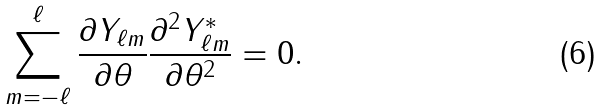Convert formula to latex. <formula><loc_0><loc_0><loc_500><loc_500>\sum _ { m = - \ell } ^ { \ell } \frac { \partial Y _ { \ell m } } { \partial \theta } \frac { \partial ^ { 2 } Y _ { \ell m } ^ { * } } { \partial \theta ^ { 2 } } = 0 .</formula> 